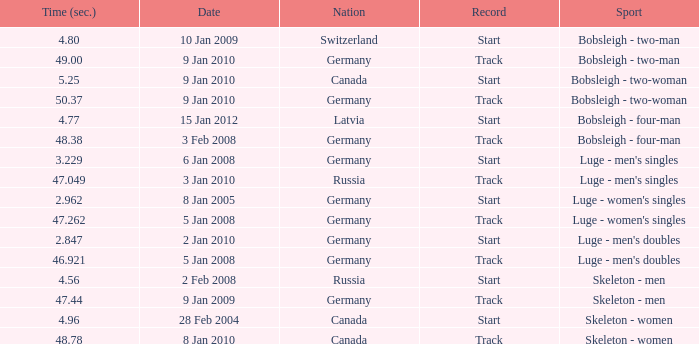For which nation was the completion time recorded as 47.049? Russia. 